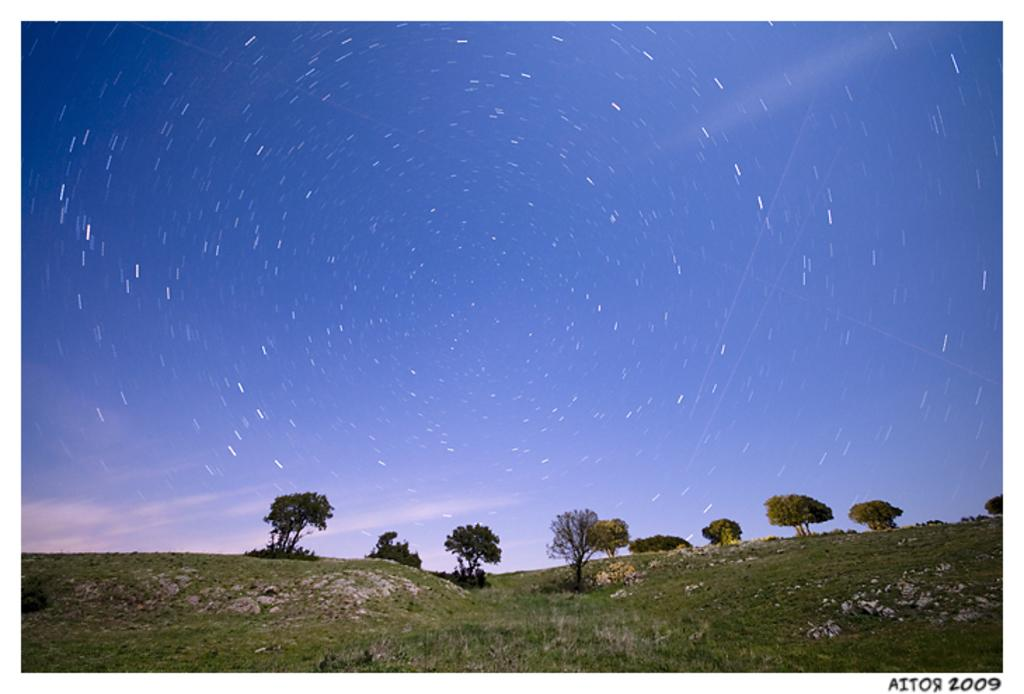What type of vegetation is in the center of the image? There are trees in the center of the image. What type of ground cover is at the bottom of the image? There is grass at the bottom of the image. What part of the natural environment is visible in the background of the image? The sky is visible in the background of the image. What language is spoken by the trees in the image? Trees do not speak any language, so this question cannot be answered. 